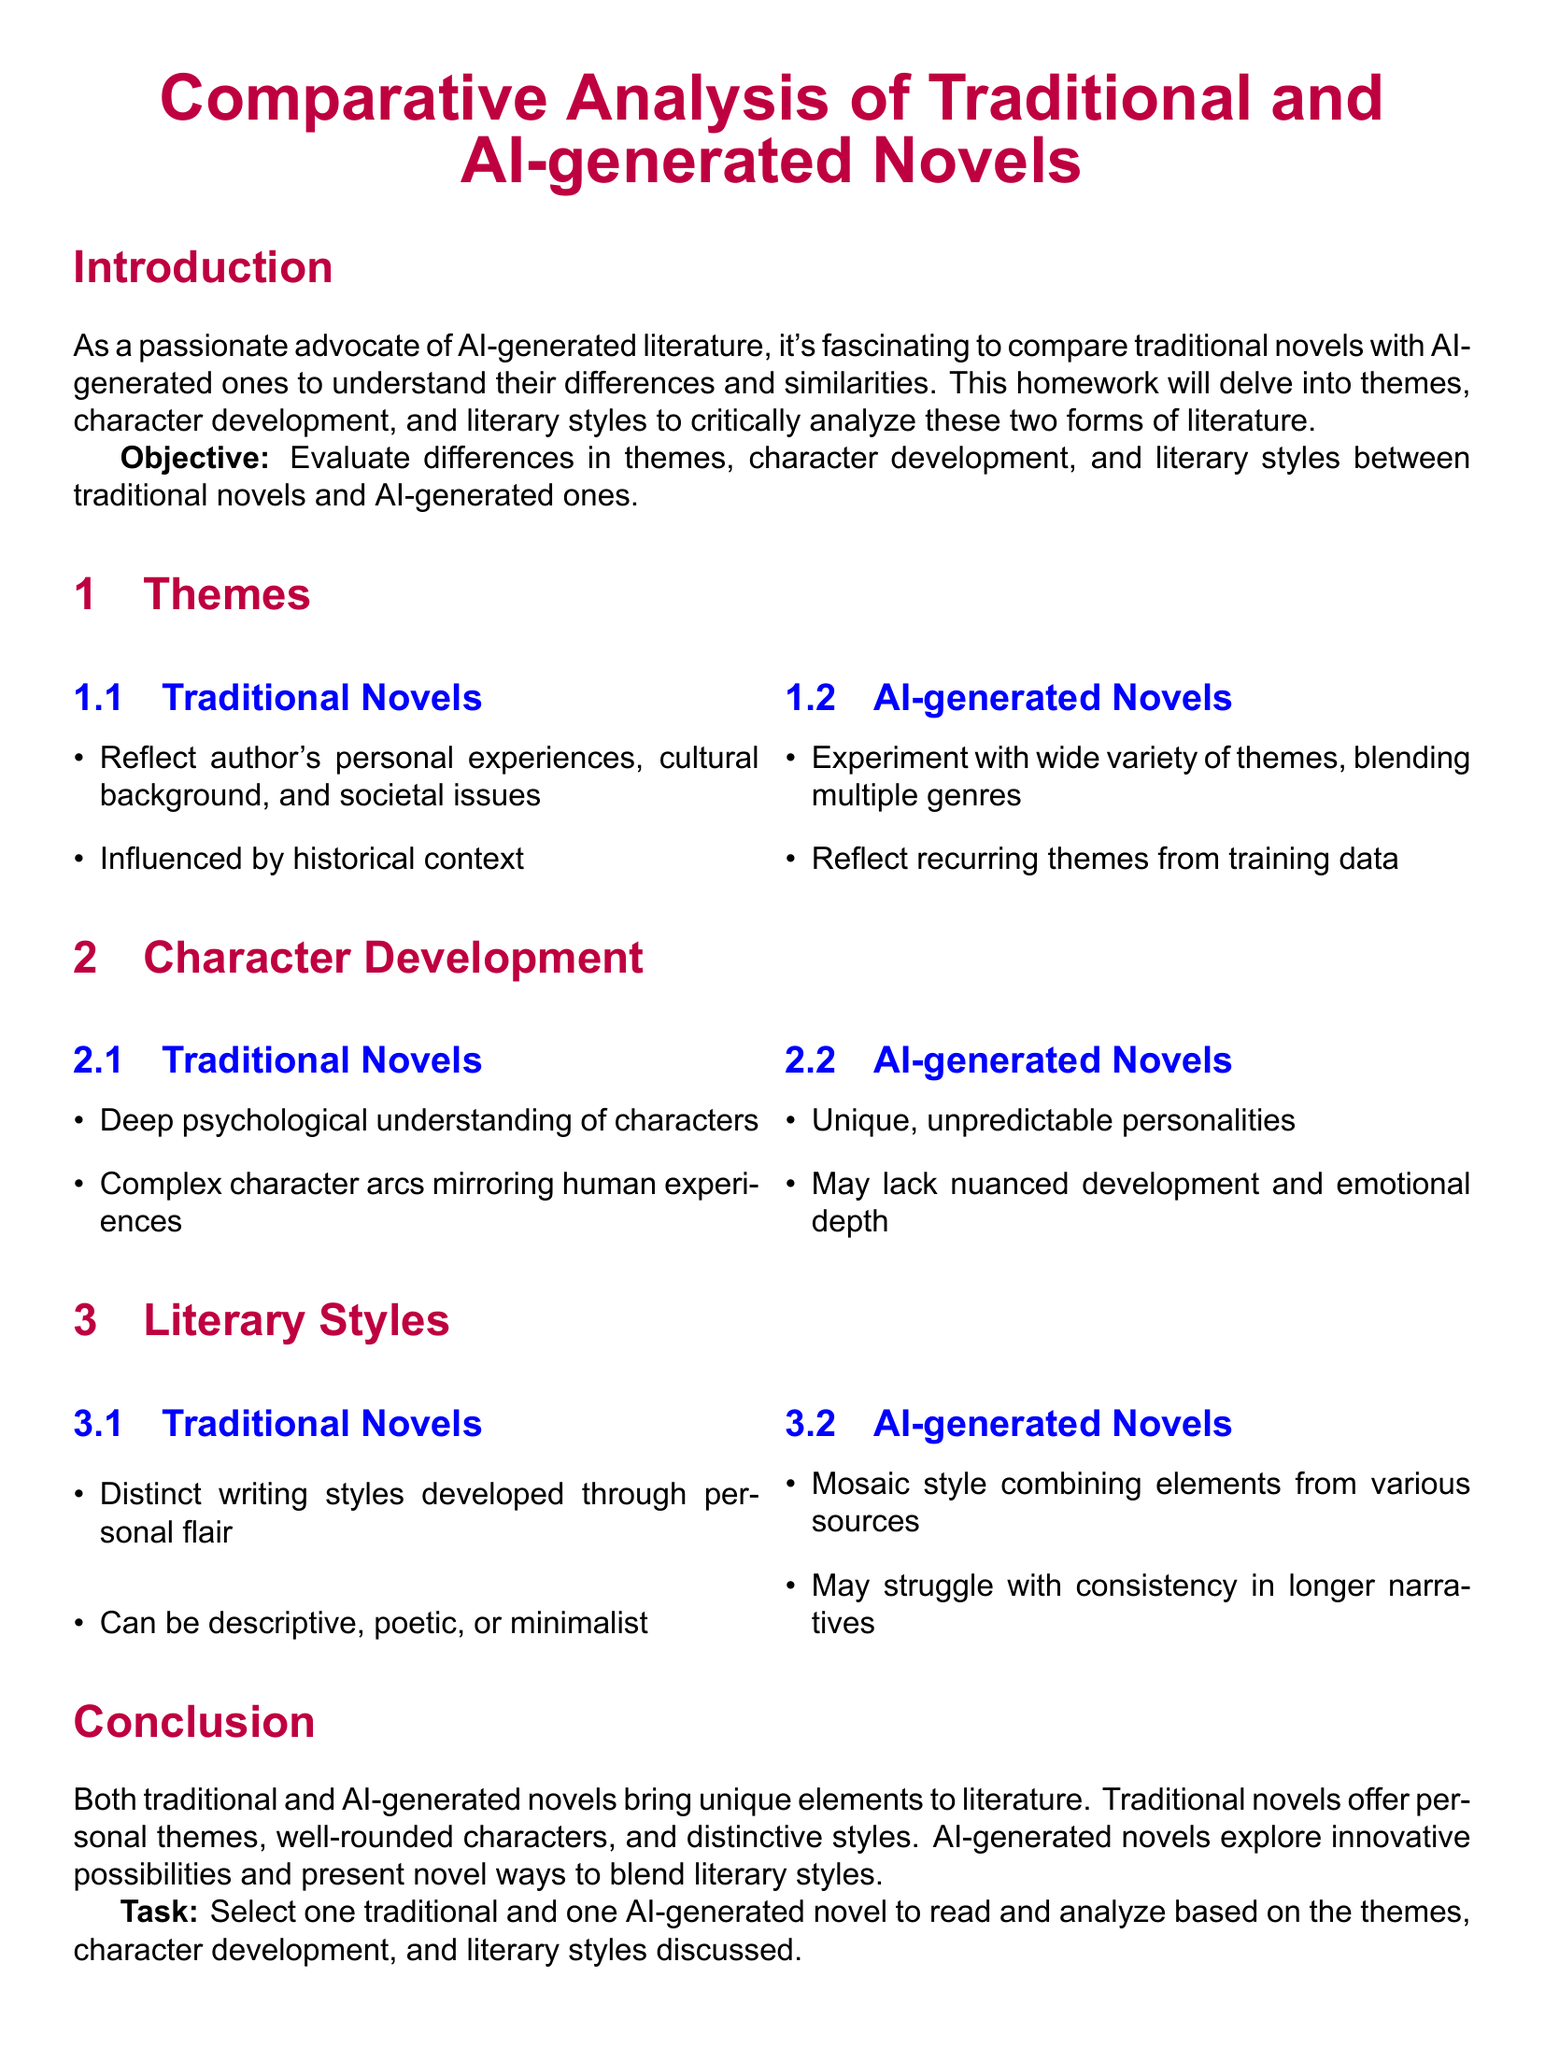What is the title of the homework document? The title of the document is stated at the beginning and is "Comparative Analysis of Traditional and AI-generated Novels."
Answer: Comparative Analysis of Traditional and AI-generated Novels What are the two main aspects evaluated in the homework? The homework focuses on differences in themes, character development, and literary styles, which are the main aspects evaluated.
Answer: Themes and character development What type of novels does the homework suggest selecting for analysis? The document mentions selecting one traditional and one AI-generated novel to read and analyze.
Answer: One traditional and one AI-generated novel In traditional novels, what understanding of characters is emphasized? The document states that traditional novels emphasize a deep psychological understanding of characters.
Answer: Deep psychological understanding What is a common characteristic of AI-generated novels’ narrative style? The homework mentions that AI-generated novels may struggle with consistency in longer narratives.
Answer: Struggle with consistency What does the conclusion highlight about traditional novels? The conclusion emphasizes that traditional novels offer personal themes, well-rounded characters, and distinctive styles.
Answer: Personal themes, well-rounded characters, distinctive styles How do AI-generated novels experiment with themes? The document states that AI-generated novels experiment with a wide variety of themes, blending multiple genres.
Answer: Blending multiple genres What psychological aspect may be lacking in AI-generated novels? The document indicates that AI-generated novels may lack nuanced development and emotional depth.
Answer: Nuanced development and emotional depth 